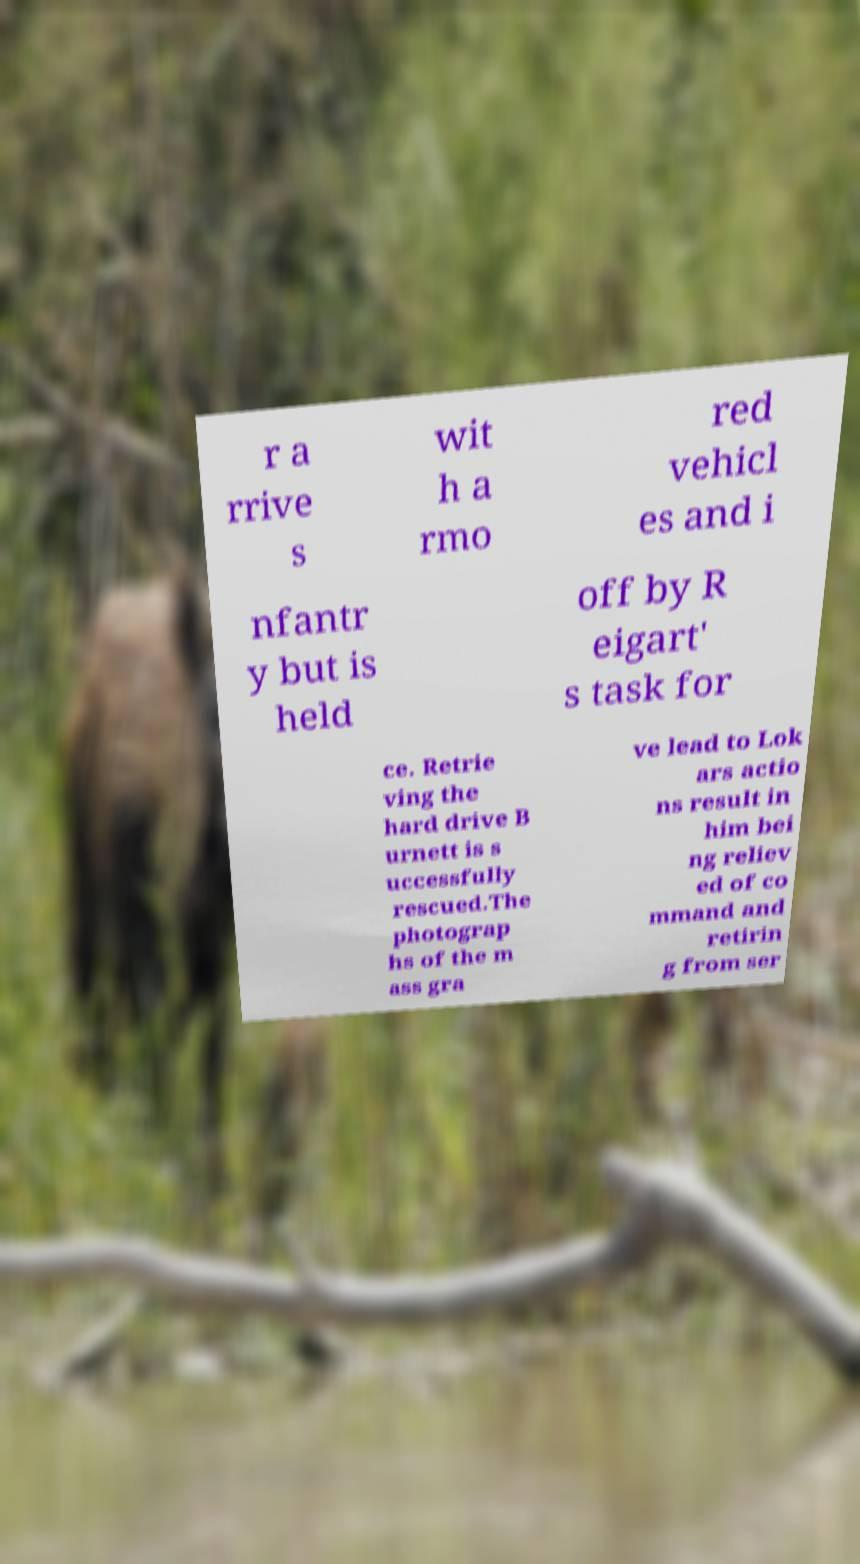Can you read and provide the text displayed in the image?This photo seems to have some interesting text. Can you extract and type it out for me? r a rrive s wit h a rmo red vehicl es and i nfantr y but is held off by R eigart' s task for ce. Retrie ving the hard drive B urnett is s uccessfully rescued.The photograp hs of the m ass gra ve lead to Lok ars actio ns result in him bei ng reliev ed of co mmand and retirin g from ser 